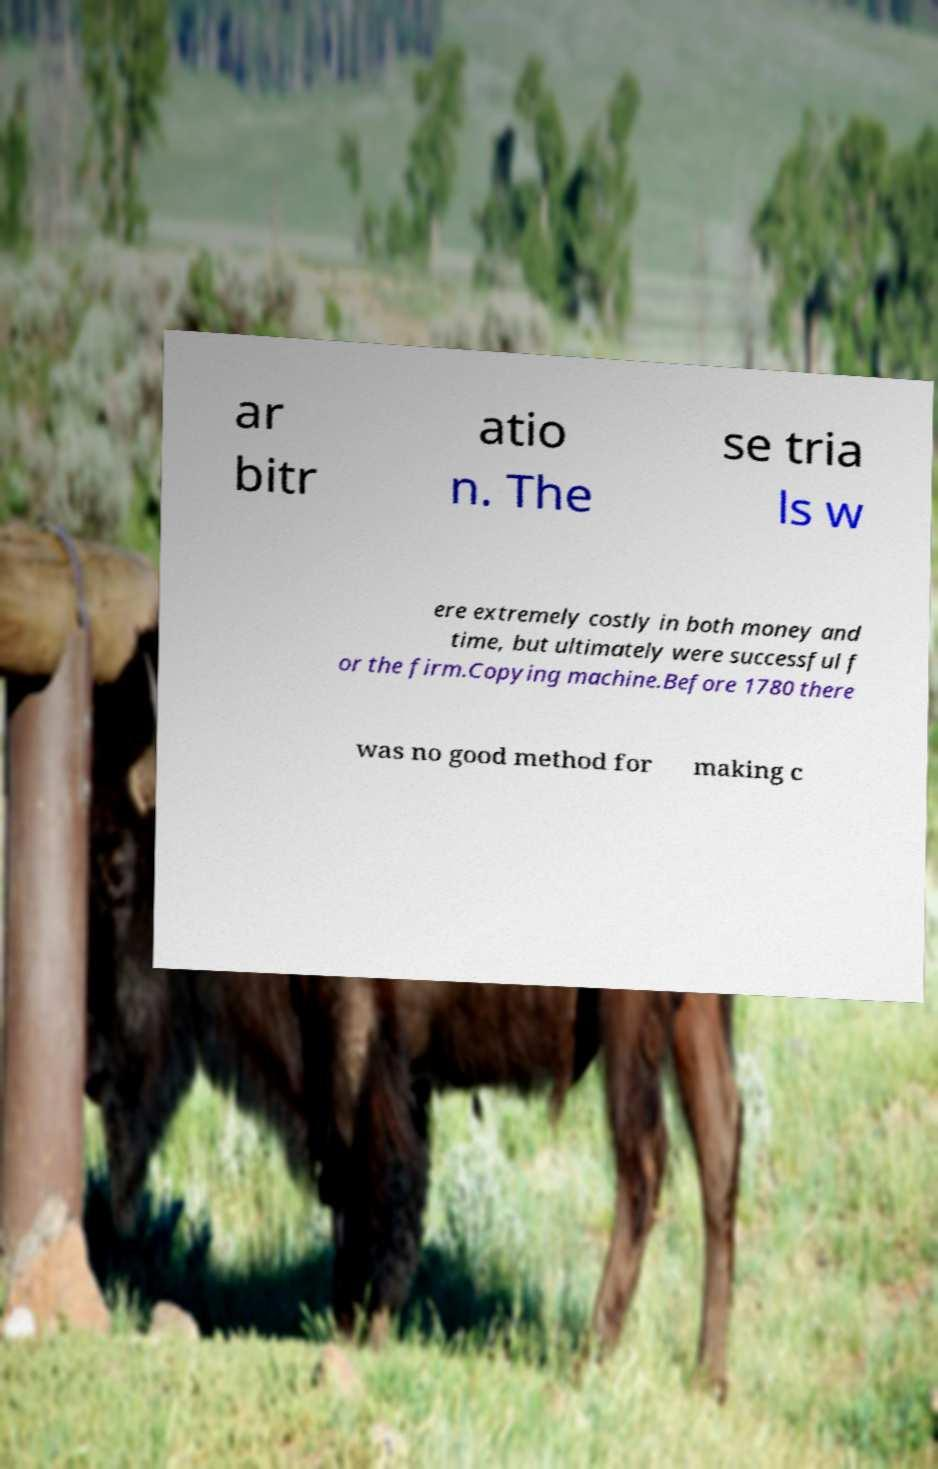There's text embedded in this image that I need extracted. Can you transcribe it verbatim? ar bitr atio n. The se tria ls w ere extremely costly in both money and time, but ultimately were successful f or the firm.Copying machine.Before 1780 there was no good method for making c 